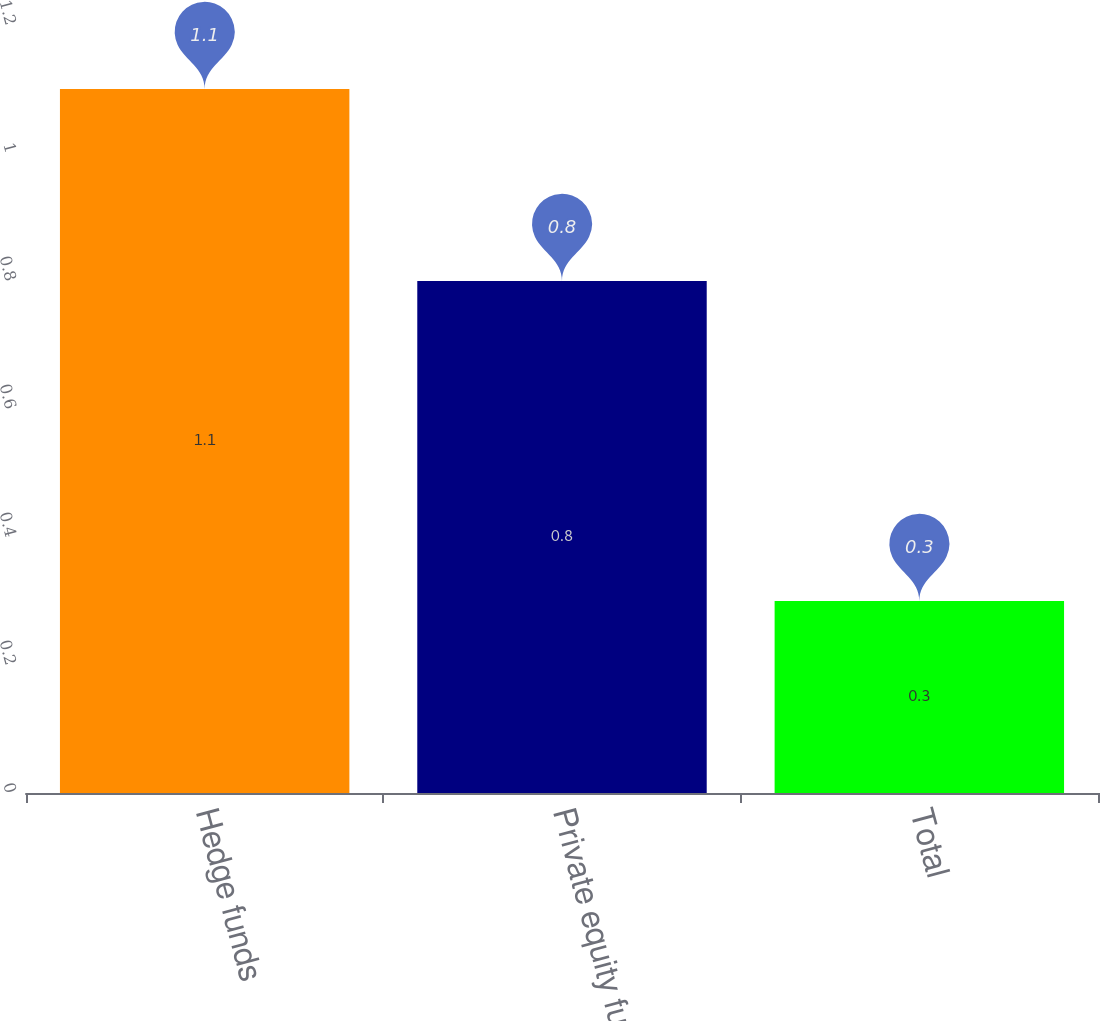Convert chart to OTSL. <chart><loc_0><loc_0><loc_500><loc_500><bar_chart><fcel>Hedge funds<fcel>Private equity funds<fcel>Total<nl><fcel>1.1<fcel>0.8<fcel>0.3<nl></chart> 